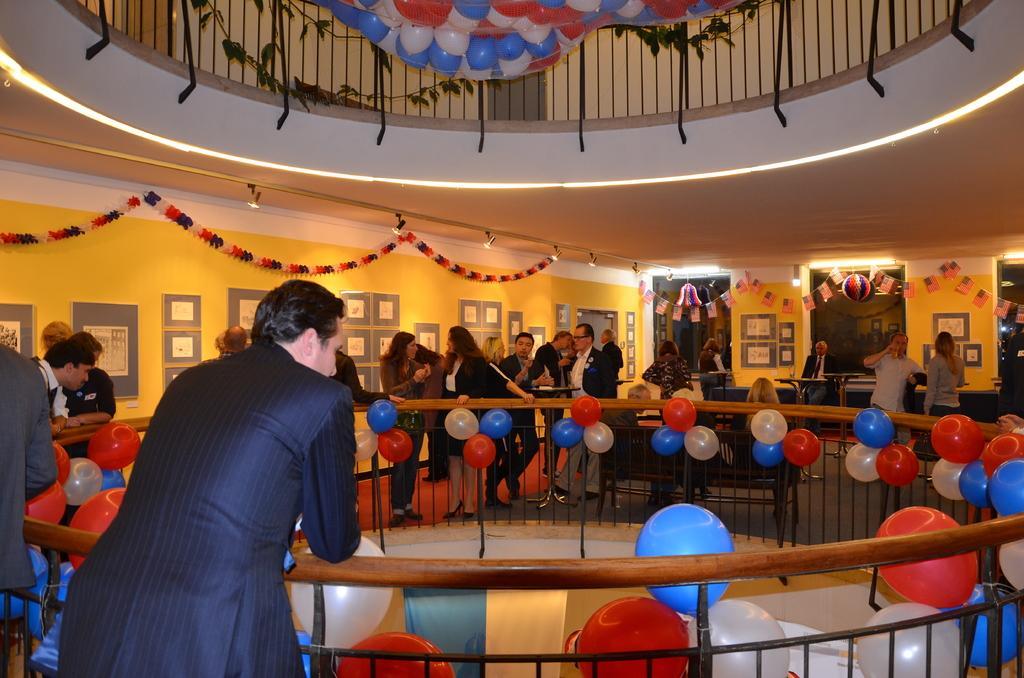Describe this image in one or two sentences. In this picture we can see the inside view of a building. Inside the building, there are groups of people, tables, a bench and some decorative objects. There are balloons to the railing. Behind the people, there are photo frames attached to the walls. At the top of the image, there are balloons, iron grille and a plant. 